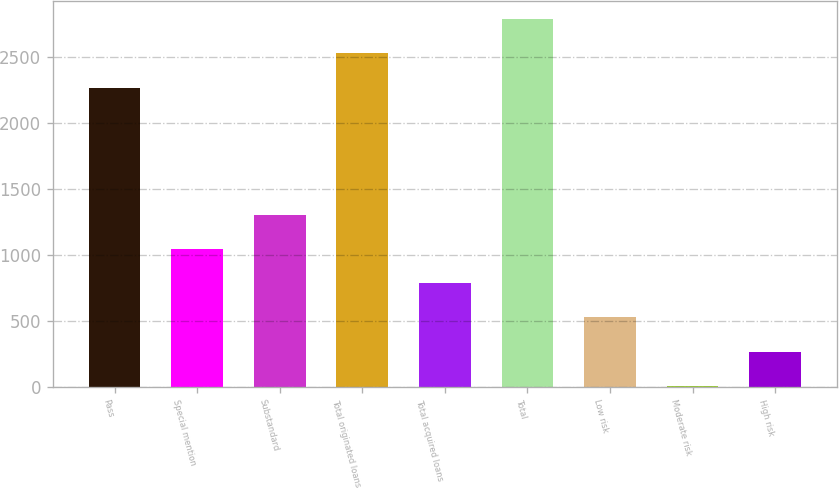Convert chart. <chart><loc_0><loc_0><loc_500><loc_500><bar_chart><fcel>Pass<fcel>Special mention<fcel>Substandard<fcel>Total originated loans<fcel>Total acquired loans<fcel>Total<fcel>Low risk<fcel>Moderate risk<fcel>High risk<nl><fcel>2262.3<fcel>1042.22<fcel>1300.7<fcel>2524.1<fcel>783.74<fcel>2782.58<fcel>525.26<fcel>8.3<fcel>266.78<nl></chart> 